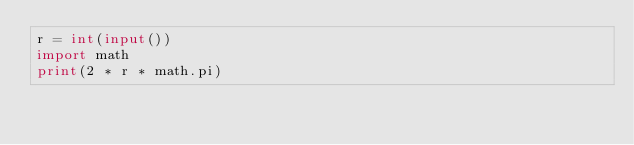<code> <loc_0><loc_0><loc_500><loc_500><_Python_>r = int(input())
import math
print(2 * r * math.pi)</code> 